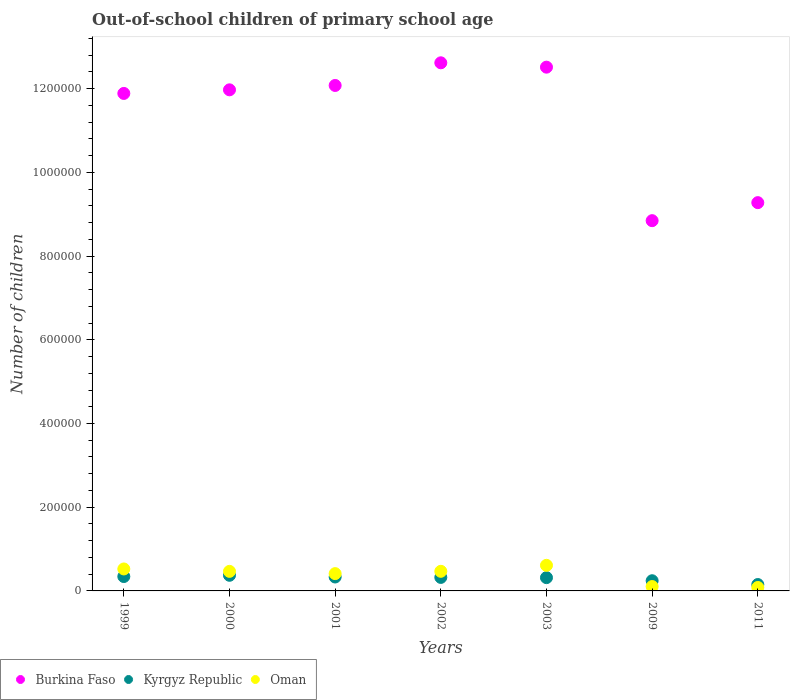What is the number of out-of-school children in Oman in 2009?
Offer a terse response. 1.05e+04. Across all years, what is the maximum number of out-of-school children in Burkina Faso?
Ensure brevity in your answer.  1.26e+06. Across all years, what is the minimum number of out-of-school children in Kyrgyz Republic?
Keep it short and to the point. 1.53e+04. In which year was the number of out-of-school children in Oman maximum?
Your answer should be compact. 2003. What is the total number of out-of-school children in Kyrgyz Republic in the graph?
Keep it short and to the point. 2.09e+05. What is the difference between the number of out-of-school children in Oman in 1999 and that in 2000?
Offer a terse response. 5778. What is the difference between the number of out-of-school children in Oman in 2002 and the number of out-of-school children in Burkina Faso in 2001?
Provide a short and direct response. -1.16e+06. What is the average number of out-of-school children in Kyrgyz Republic per year?
Provide a short and direct response. 2.98e+04. In the year 2009, what is the difference between the number of out-of-school children in Burkina Faso and number of out-of-school children in Kyrgyz Republic?
Your response must be concise. 8.60e+05. What is the ratio of the number of out-of-school children in Oman in 2001 to that in 2003?
Offer a very short reply. 0.68. Is the difference between the number of out-of-school children in Burkina Faso in 2001 and 2002 greater than the difference between the number of out-of-school children in Kyrgyz Republic in 2001 and 2002?
Your response must be concise. No. What is the difference between the highest and the second highest number of out-of-school children in Kyrgyz Republic?
Give a very brief answer. 2965. What is the difference between the highest and the lowest number of out-of-school children in Kyrgyz Republic?
Make the answer very short. 2.21e+04. Is it the case that in every year, the sum of the number of out-of-school children in Kyrgyz Republic and number of out-of-school children in Oman  is greater than the number of out-of-school children in Burkina Faso?
Your response must be concise. No. Is the number of out-of-school children in Burkina Faso strictly less than the number of out-of-school children in Kyrgyz Republic over the years?
Make the answer very short. No. Are the values on the major ticks of Y-axis written in scientific E-notation?
Offer a very short reply. No. How many legend labels are there?
Ensure brevity in your answer.  3. How are the legend labels stacked?
Keep it short and to the point. Horizontal. What is the title of the graph?
Your answer should be very brief. Out-of-school children of primary school age. What is the label or title of the Y-axis?
Your answer should be very brief. Number of children. What is the Number of children of Burkina Faso in 1999?
Give a very brief answer. 1.19e+06. What is the Number of children of Kyrgyz Republic in 1999?
Keep it short and to the point. 3.44e+04. What is the Number of children of Oman in 1999?
Ensure brevity in your answer.  5.25e+04. What is the Number of children in Burkina Faso in 2000?
Provide a short and direct response. 1.20e+06. What is the Number of children in Kyrgyz Republic in 2000?
Give a very brief answer. 3.73e+04. What is the Number of children in Oman in 2000?
Offer a terse response. 4.67e+04. What is the Number of children of Burkina Faso in 2001?
Provide a short and direct response. 1.21e+06. What is the Number of children in Kyrgyz Republic in 2001?
Your answer should be compact. 3.33e+04. What is the Number of children in Oman in 2001?
Your response must be concise. 4.13e+04. What is the Number of children in Burkina Faso in 2002?
Offer a terse response. 1.26e+06. What is the Number of children in Kyrgyz Republic in 2002?
Provide a short and direct response. 3.23e+04. What is the Number of children of Oman in 2002?
Make the answer very short. 4.68e+04. What is the Number of children of Burkina Faso in 2003?
Ensure brevity in your answer.  1.25e+06. What is the Number of children in Kyrgyz Republic in 2003?
Your answer should be compact. 3.17e+04. What is the Number of children of Oman in 2003?
Keep it short and to the point. 6.11e+04. What is the Number of children in Burkina Faso in 2009?
Make the answer very short. 8.85e+05. What is the Number of children in Kyrgyz Republic in 2009?
Ensure brevity in your answer.  2.43e+04. What is the Number of children of Oman in 2009?
Give a very brief answer. 1.05e+04. What is the Number of children of Burkina Faso in 2011?
Offer a terse response. 9.28e+05. What is the Number of children of Kyrgyz Republic in 2011?
Offer a very short reply. 1.53e+04. What is the Number of children in Oman in 2011?
Your response must be concise. 8213. Across all years, what is the maximum Number of children of Burkina Faso?
Offer a very short reply. 1.26e+06. Across all years, what is the maximum Number of children in Kyrgyz Republic?
Your answer should be compact. 3.73e+04. Across all years, what is the maximum Number of children in Oman?
Keep it short and to the point. 6.11e+04. Across all years, what is the minimum Number of children of Burkina Faso?
Your answer should be compact. 8.85e+05. Across all years, what is the minimum Number of children of Kyrgyz Republic?
Provide a succinct answer. 1.53e+04. Across all years, what is the minimum Number of children in Oman?
Your response must be concise. 8213. What is the total Number of children of Burkina Faso in the graph?
Your response must be concise. 7.92e+06. What is the total Number of children in Kyrgyz Republic in the graph?
Keep it short and to the point. 2.09e+05. What is the total Number of children in Oman in the graph?
Make the answer very short. 2.67e+05. What is the difference between the Number of children in Burkina Faso in 1999 and that in 2000?
Provide a succinct answer. -8593. What is the difference between the Number of children in Kyrgyz Republic in 1999 and that in 2000?
Provide a succinct answer. -2965. What is the difference between the Number of children in Oman in 1999 and that in 2000?
Give a very brief answer. 5778. What is the difference between the Number of children in Burkina Faso in 1999 and that in 2001?
Your answer should be very brief. -1.90e+04. What is the difference between the Number of children of Kyrgyz Republic in 1999 and that in 2001?
Provide a short and direct response. 1127. What is the difference between the Number of children of Oman in 1999 and that in 2001?
Your response must be concise. 1.12e+04. What is the difference between the Number of children in Burkina Faso in 1999 and that in 2002?
Your response must be concise. -7.32e+04. What is the difference between the Number of children in Kyrgyz Republic in 1999 and that in 2002?
Your answer should be very brief. 2106. What is the difference between the Number of children in Oman in 1999 and that in 2002?
Provide a succinct answer. 5643. What is the difference between the Number of children of Burkina Faso in 1999 and that in 2003?
Provide a succinct answer. -6.28e+04. What is the difference between the Number of children in Kyrgyz Republic in 1999 and that in 2003?
Make the answer very short. 2649. What is the difference between the Number of children of Oman in 1999 and that in 2003?
Your answer should be compact. -8659. What is the difference between the Number of children of Burkina Faso in 1999 and that in 2009?
Ensure brevity in your answer.  3.04e+05. What is the difference between the Number of children of Kyrgyz Republic in 1999 and that in 2009?
Ensure brevity in your answer.  1.01e+04. What is the difference between the Number of children in Oman in 1999 and that in 2009?
Your response must be concise. 4.20e+04. What is the difference between the Number of children of Burkina Faso in 1999 and that in 2011?
Make the answer very short. 2.61e+05. What is the difference between the Number of children of Kyrgyz Republic in 1999 and that in 2011?
Your answer should be compact. 1.91e+04. What is the difference between the Number of children of Oman in 1999 and that in 2011?
Provide a short and direct response. 4.43e+04. What is the difference between the Number of children of Burkina Faso in 2000 and that in 2001?
Your answer should be very brief. -1.05e+04. What is the difference between the Number of children of Kyrgyz Republic in 2000 and that in 2001?
Make the answer very short. 4092. What is the difference between the Number of children of Oman in 2000 and that in 2001?
Ensure brevity in your answer.  5378. What is the difference between the Number of children in Burkina Faso in 2000 and that in 2002?
Your answer should be very brief. -6.46e+04. What is the difference between the Number of children of Kyrgyz Republic in 2000 and that in 2002?
Give a very brief answer. 5071. What is the difference between the Number of children of Oman in 2000 and that in 2002?
Keep it short and to the point. -135. What is the difference between the Number of children in Burkina Faso in 2000 and that in 2003?
Offer a terse response. -5.42e+04. What is the difference between the Number of children of Kyrgyz Republic in 2000 and that in 2003?
Your answer should be compact. 5614. What is the difference between the Number of children of Oman in 2000 and that in 2003?
Offer a terse response. -1.44e+04. What is the difference between the Number of children in Burkina Faso in 2000 and that in 2009?
Offer a terse response. 3.13e+05. What is the difference between the Number of children in Kyrgyz Republic in 2000 and that in 2009?
Provide a succinct answer. 1.30e+04. What is the difference between the Number of children of Oman in 2000 and that in 2009?
Provide a succinct answer. 3.62e+04. What is the difference between the Number of children in Burkina Faso in 2000 and that in 2011?
Ensure brevity in your answer.  2.70e+05. What is the difference between the Number of children in Kyrgyz Republic in 2000 and that in 2011?
Provide a succinct answer. 2.21e+04. What is the difference between the Number of children of Oman in 2000 and that in 2011?
Offer a terse response. 3.85e+04. What is the difference between the Number of children of Burkina Faso in 2001 and that in 2002?
Give a very brief answer. -5.41e+04. What is the difference between the Number of children in Kyrgyz Republic in 2001 and that in 2002?
Your answer should be very brief. 979. What is the difference between the Number of children of Oman in 2001 and that in 2002?
Your answer should be very brief. -5513. What is the difference between the Number of children in Burkina Faso in 2001 and that in 2003?
Keep it short and to the point. -4.37e+04. What is the difference between the Number of children in Kyrgyz Republic in 2001 and that in 2003?
Offer a very short reply. 1522. What is the difference between the Number of children of Oman in 2001 and that in 2003?
Offer a terse response. -1.98e+04. What is the difference between the Number of children of Burkina Faso in 2001 and that in 2009?
Provide a short and direct response. 3.23e+05. What is the difference between the Number of children of Kyrgyz Republic in 2001 and that in 2009?
Give a very brief answer. 8935. What is the difference between the Number of children in Oman in 2001 and that in 2009?
Your response must be concise. 3.09e+04. What is the difference between the Number of children of Burkina Faso in 2001 and that in 2011?
Your answer should be compact. 2.80e+05. What is the difference between the Number of children in Kyrgyz Republic in 2001 and that in 2011?
Your answer should be very brief. 1.80e+04. What is the difference between the Number of children of Oman in 2001 and that in 2011?
Keep it short and to the point. 3.31e+04. What is the difference between the Number of children in Burkina Faso in 2002 and that in 2003?
Your answer should be very brief. 1.04e+04. What is the difference between the Number of children of Kyrgyz Republic in 2002 and that in 2003?
Offer a very short reply. 543. What is the difference between the Number of children of Oman in 2002 and that in 2003?
Provide a short and direct response. -1.43e+04. What is the difference between the Number of children in Burkina Faso in 2002 and that in 2009?
Offer a very short reply. 3.77e+05. What is the difference between the Number of children in Kyrgyz Republic in 2002 and that in 2009?
Provide a succinct answer. 7956. What is the difference between the Number of children of Oman in 2002 and that in 2009?
Your response must be concise. 3.64e+04. What is the difference between the Number of children in Burkina Faso in 2002 and that in 2011?
Ensure brevity in your answer.  3.34e+05. What is the difference between the Number of children in Kyrgyz Republic in 2002 and that in 2011?
Your answer should be very brief. 1.70e+04. What is the difference between the Number of children of Oman in 2002 and that in 2011?
Provide a succinct answer. 3.86e+04. What is the difference between the Number of children of Burkina Faso in 2003 and that in 2009?
Offer a terse response. 3.67e+05. What is the difference between the Number of children of Kyrgyz Republic in 2003 and that in 2009?
Ensure brevity in your answer.  7413. What is the difference between the Number of children in Oman in 2003 and that in 2009?
Give a very brief answer. 5.07e+04. What is the difference between the Number of children of Burkina Faso in 2003 and that in 2011?
Offer a terse response. 3.24e+05. What is the difference between the Number of children in Kyrgyz Republic in 2003 and that in 2011?
Give a very brief answer. 1.65e+04. What is the difference between the Number of children in Oman in 2003 and that in 2011?
Provide a short and direct response. 5.29e+04. What is the difference between the Number of children of Burkina Faso in 2009 and that in 2011?
Provide a succinct answer. -4.31e+04. What is the difference between the Number of children in Kyrgyz Republic in 2009 and that in 2011?
Give a very brief answer. 9065. What is the difference between the Number of children in Oman in 2009 and that in 2011?
Keep it short and to the point. 2264. What is the difference between the Number of children in Burkina Faso in 1999 and the Number of children in Kyrgyz Republic in 2000?
Your answer should be compact. 1.15e+06. What is the difference between the Number of children in Burkina Faso in 1999 and the Number of children in Oman in 2000?
Provide a short and direct response. 1.14e+06. What is the difference between the Number of children in Kyrgyz Republic in 1999 and the Number of children in Oman in 2000?
Offer a very short reply. -1.23e+04. What is the difference between the Number of children of Burkina Faso in 1999 and the Number of children of Kyrgyz Republic in 2001?
Your answer should be very brief. 1.16e+06. What is the difference between the Number of children in Burkina Faso in 1999 and the Number of children in Oman in 2001?
Your answer should be very brief. 1.15e+06. What is the difference between the Number of children of Kyrgyz Republic in 1999 and the Number of children of Oman in 2001?
Your answer should be very brief. -6947. What is the difference between the Number of children of Burkina Faso in 1999 and the Number of children of Kyrgyz Republic in 2002?
Provide a succinct answer. 1.16e+06. What is the difference between the Number of children in Burkina Faso in 1999 and the Number of children in Oman in 2002?
Ensure brevity in your answer.  1.14e+06. What is the difference between the Number of children in Kyrgyz Republic in 1999 and the Number of children in Oman in 2002?
Your response must be concise. -1.25e+04. What is the difference between the Number of children in Burkina Faso in 1999 and the Number of children in Kyrgyz Republic in 2003?
Ensure brevity in your answer.  1.16e+06. What is the difference between the Number of children in Burkina Faso in 1999 and the Number of children in Oman in 2003?
Offer a very short reply. 1.13e+06. What is the difference between the Number of children in Kyrgyz Republic in 1999 and the Number of children in Oman in 2003?
Offer a terse response. -2.68e+04. What is the difference between the Number of children of Burkina Faso in 1999 and the Number of children of Kyrgyz Republic in 2009?
Your answer should be compact. 1.16e+06. What is the difference between the Number of children of Burkina Faso in 1999 and the Number of children of Oman in 2009?
Your response must be concise. 1.18e+06. What is the difference between the Number of children of Kyrgyz Republic in 1999 and the Number of children of Oman in 2009?
Provide a short and direct response. 2.39e+04. What is the difference between the Number of children of Burkina Faso in 1999 and the Number of children of Kyrgyz Republic in 2011?
Your answer should be very brief. 1.17e+06. What is the difference between the Number of children in Burkina Faso in 1999 and the Number of children in Oman in 2011?
Make the answer very short. 1.18e+06. What is the difference between the Number of children in Kyrgyz Republic in 1999 and the Number of children in Oman in 2011?
Provide a succinct answer. 2.62e+04. What is the difference between the Number of children of Burkina Faso in 2000 and the Number of children of Kyrgyz Republic in 2001?
Offer a terse response. 1.16e+06. What is the difference between the Number of children in Burkina Faso in 2000 and the Number of children in Oman in 2001?
Offer a terse response. 1.16e+06. What is the difference between the Number of children in Kyrgyz Republic in 2000 and the Number of children in Oman in 2001?
Ensure brevity in your answer.  -3982. What is the difference between the Number of children of Burkina Faso in 2000 and the Number of children of Kyrgyz Republic in 2002?
Ensure brevity in your answer.  1.17e+06. What is the difference between the Number of children in Burkina Faso in 2000 and the Number of children in Oman in 2002?
Give a very brief answer. 1.15e+06. What is the difference between the Number of children of Kyrgyz Republic in 2000 and the Number of children of Oman in 2002?
Make the answer very short. -9495. What is the difference between the Number of children in Burkina Faso in 2000 and the Number of children in Kyrgyz Republic in 2003?
Your response must be concise. 1.17e+06. What is the difference between the Number of children of Burkina Faso in 2000 and the Number of children of Oman in 2003?
Offer a very short reply. 1.14e+06. What is the difference between the Number of children in Kyrgyz Republic in 2000 and the Number of children in Oman in 2003?
Provide a short and direct response. -2.38e+04. What is the difference between the Number of children in Burkina Faso in 2000 and the Number of children in Kyrgyz Republic in 2009?
Keep it short and to the point. 1.17e+06. What is the difference between the Number of children of Burkina Faso in 2000 and the Number of children of Oman in 2009?
Provide a succinct answer. 1.19e+06. What is the difference between the Number of children of Kyrgyz Republic in 2000 and the Number of children of Oman in 2009?
Your answer should be very brief. 2.69e+04. What is the difference between the Number of children in Burkina Faso in 2000 and the Number of children in Kyrgyz Republic in 2011?
Make the answer very short. 1.18e+06. What is the difference between the Number of children in Burkina Faso in 2000 and the Number of children in Oman in 2011?
Ensure brevity in your answer.  1.19e+06. What is the difference between the Number of children of Kyrgyz Republic in 2000 and the Number of children of Oman in 2011?
Offer a terse response. 2.91e+04. What is the difference between the Number of children in Burkina Faso in 2001 and the Number of children in Kyrgyz Republic in 2002?
Your answer should be very brief. 1.18e+06. What is the difference between the Number of children of Burkina Faso in 2001 and the Number of children of Oman in 2002?
Make the answer very short. 1.16e+06. What is the difference between the Number of children of Kyrgyz Republic in 2001 and the Number of children of Oman in 2002?
Provide a short and direct response. -1.36e+04. What is the difference between the Number of children in Burkina Faso in 2001 and the Number of children in Kyrgyz Republic in 2003?
Give a very brief answer. 1.18e+06. What is the difference between the Number of children of Burkina Faso in 2001 and the Number of children of Oman in 2003?
Ensure brevity in your answer.  1.15e+06. What is the difference between the Number of children of Kyrgyz Republic in 2001 and the Number of children of Oman in 2003?
Your answer should be compact. -2.79e+04. What is the difference between the Number of children in Burkina Faso in 2001 and the Number of children in Kyrgyz Republic in 2009?
Ensure brevity in your answer.  1.18e+06. What is the difference between the Number of children of Burkina Faso in 2001 and the Number of children of Oman in 2009?
Ensure brevity in your answer.  1.20e+06. What is the difference between the Number of children in Kyrgyz Republic in 2001 and the Number of children in Oman in 2009?
Your response must be concise. 2.28e+04. What is the difference between the Number of children in Burkina Faso in 2001 and the Number of children in Kyrgyz Republic in 2011?
Your answer should be very brief. 1.19e+06. What is the difference between the Number of children of Burkina Faso in 2001 and the Number of children of Oman in 2011?
Make the answer very short. 1.20e+06. What is the difference between the Number of children in Kyrgyz Republic in 2001 and the Number of children in Oman in 2011?
Your response must be concise. 2.50e+04. What is the difference between the Number of children in Burkina Faso in 2002 and the Number of children in Kyrgyz Republic in 2003?
Your answer should be very brief. 1.23e+06. What is the difference between the Number of children in Burkina Faso in 2002 and the Number of children in Oman in 2003?
Your answer should be compact. 1.20e+06. What is the difference between the Number of children of Kyrgyz Republic in 2002 and the Number of children of Oman in 2003?
Your answer should be very brief. -2.89e+04. What is the difference between the Number of children in Burkina Faso in 2002 and the Number of children in Kyrgyz Republic in 2009?
Give a very brief answer. 1.24e+06. What is the difference between the Number of children in Burkina Faso in 2002 and the Number of children in Oman in 2009?
Your answer should be compact. 1.25e+06. What is the difference between the Number of children in Kyrgyz Republic in 2002 and the Number of children in Oman in 2009?
Keep it short and to the point. 2.18e+04. What is the difference between the Number of children in Burkina Faso in 2002 and the Number of children in Kyrgyz Republic in 2011?
Your response must be concise. 1.25e+06. What is the difference between the Number of children in Burkina Faso in 2002 and the Number of children in Oman in 2011?
Offer a terse response. 1.25e+06. What is the difference between the Number of children of Kyrgyz Republic in 2002 and the Number of children of Oman in 2011?
Make the answer very short. 2.41e+04. What is the difference between the Number of children in Burkina Faso in 2003 and the Number of children in Kyrgyz Republic in 2009?
Keep it short and to the point. 1.23e+06. What is the difference between the Number of children in Burkina Faso in 2003 and the Number of children in Oman in 2009?
Provide a succinct answer. 1.24e+06. What is the difference between the Number of children of Kyrgyz Republic in 2003 and the Number of children of Oman in 2009?
Ensure brevity in your answer.  2.13e+04. What is the difference between the Number of children in Burkina Faso in 2003 and the Number of children in Kyrgyz Republic in 2011?
Your response must be concise. 1.24e+06. What is the difference between the Number of children of Burkina Faso in 2003 and the Number of children of Oman in 2011?
Give a very brief answer. 1.24e+06. What is the difference between the Number of children in Kyrgyz Republic in 2003 and the Number of children in Oman in 2011?
Offer a terse response. 2.35e+04. What is the difference between the Number of children in Burkina Faso in 2009 and the Number of children in Kyrgyz Republic in 2011?
Ensure brevity in your answer.  8.69e+05. What is the difference between the Number of children of Burkina Faso in 2009 and the Number of children of Oman in 2011?
Your answer should be very brief. 8.76e+05. What is the difference between the Number of children of Kyrgyz Republic in 2009 and the Number of children of Oman in 2011?
Your response must be concise. 1.61e+04. What is the average Number of children in Burkina Faso per year?
Give a very brief answer. 1.13e+06. What is the average Number of children in Kyrgyz Republic per year?
Offer a terse response. 2.98e+04. What is the average Number of children in Oman per year?
Ensure brevity in your answer.  3.82e+04. In the year 1999, what is the difference between the Number of children of Burkina Faso and Number of children of Kyrgyz Republic?
Make the answer very short. 1.15e+06. In the year 1999, what is the difference between the Number of children in Burkina Faso and Number of children in Oman?
Your answer should be very brief. 1.14e+06. In the year 1999, what is the difference between the Number of children in Kyrgyz Republic and Number of children in Oman?
Provide a succinct answer. -1.81e+04. In the year 2000, what is the difference between the Number of children of Burkina Faso and Number of children of Kyrgyz Republic?
Make the answer very short. 1.16e+06. In the year 2000, what is the difference between the Number of children of Burkina Faso and Number of children of Oman?
Your response must be concise. 1.15e+06. In the year 2000, what is the difference between the Number of children of Kyrgyz Republic and Number of children of Oman?
Provide a short and direct response. -9360. In the year 2001, what is the difference between the Number of children of Burkina Faso and Number of children of Kyrgyz Republic?
Give a very brief answer. 1.17e+06. In the year 2001, what is the difference between the Number of children of Burkina Faso and Number of children of Oman?
Offer a terse response. 1.17e+06. In the year 2001, what is the difference between the Number of children in Kyrgyz Republic and Number of children in Oman?
Your answer should be compact. -8074. In the year 2002, what is the difference between the Number of children of Burkina Faso and Number of children of Kyrgyz Republic?
Your response must be concise. 1.23e+06. In the year 2002, what is the difference between the Number of children of Burkina Faso and Number of children of Oman?
Your response must be concise. 1.22e+06. In the year 2002, what is the difference between the Number of children of Kyrgyz Republic and Number of children of Oman?
Your response must be concise. -1.46e+04. In the year 2003, what is the difference between the Number of children in Burkina Faso and Number of children in Kyrgyz Republic?
Offer a terse response. 1.22e+06. In the year 2003, what is the difference between the Number of children in Burkina Faso and Number of children in Oman?
Provide a short and direct response. 1.19e+06. In the year 2003, what is the difference between the Number of children of Kyrgyz Republic and Number of children of Oman?
Ensure brevity in your answer.  -2.94e+04. In the year 2009, what is the difference between the Number of children in Burkina Faso and Number of children in Kyrgyz Republic?
Provide a short and direct response. 8.60e+05. In the year 2009, what is the difference between the Number of children of Burkina Faso and Number of children of Oman?
Keep it short and to the point. 8.74e+05. In the year 2009, what is the difference between the Number of children in Kyrgyz Republic and Number of children in Oman?
Give a very brief answer. 1.38e+04. In the year 2011, what is the difference between the Number of children of Burkina Faso and Number of children of Kyrgyz Republic?
Your answer should be compact. 9.12e+05. In the year 2011, what is the difference between the Number of children of Burkina Faso and Number of children of Oman?
Offer a very short reply. 9.20e+05. In the year 2011, what is the difference between the Number of children of Kyrgyz Republic and Number of children of Oman?
Provide a short and direct response. 7043. What is the ratio of the Number of children in Burkina Faso in 1999 to that in 2000?
Give a very brief answer. 0.99. What is the ratio of the Number of children in Kyrgyz Republic in 1999 to that in 2000?
Give a very brief answer. 0.92. What is the ratio of the Number of children of Oman in 1999 to that in 2000?
Make the answer very short. 1.12. What is the ratio of the Number of children in Burkina Faso in 1999 to that in 2001?
Ensure brevity in your answer.  0.98. What is the ratio of the Number of children of Kyrgyz Republic in 1999 to that in 2001?
Give a very brief answer. 1.03. What is the ratio of the Number of children in Oman in 1999 to that in 2001?
Make the answer very short. 1.27. What is the ratio of the Number of children of Burkina Faso in 1999 to that in 2002?
Your answer should be very brief. 0.94. What is the ratio of the Number of children of Kyrgyz Republic in 1999 to that in 2002?
Ensure brevity in your answer.  1.07. What is the ratio of the Number of children in Oman in 1999 to that in 2002?
Your response must be concise. 1.12. What is the ratio of the Number of children in Burkina Faso in 1999 to that in 2003?
Offer a terse response. 0.95. What is the ratio of the Number of children of Kyrgyz Republic in 1999 to that in 2003?
Ensure brevity in your answer.  1.08. What is the ratio of the Number of children of Oman in 1999 to that in 2003?
Give a very brief answer. 0.86. What is the ratio of the Number of children of Burkina Faso in 1999 to that in 2009?
Offer a very short reply. 1.34. What is the ratio of the Number of children of Kyrgyz Republic in 1999 to that in 2009?
Your response must be concise. 1.41. What is the ratio of the Number of children in Oman in 1999 to that in 2009?
Give a very brief answer. 5.01. What is the ratio of the Number of children in Burkina Faso in 1999 to that in 2011?
Offer a very short reply. 1.28. What is the ratio of the Number of children of Kyrgyz Republic in 1999 to that in 2011?
Your response must be concise. 2.25. What is the ratio of the Number of children in Oman in 1999 to that in 2011?
Your answer should be compact. 6.39. What is the ratio of the Number of children in Burkina Faso in 2000 to that in 2001?
Provide a succinct answer. 0.99. What is the ratio of the Number of children in Kyrgyz Republic in 2000 to that in 2001?
Offer a terse response. 1.12. What is the ratio of the Number of children of Oman in 2000 to that in 2001?
Your response must be concise. 1.13. What is the ratio of the Number of children of Burkina Faso in 2000 to that in 2002?
Offer a terse response. 0.95. What is the ratio of the Number of children of Kyrgyz Republic in 2000 to that in 2002?
Your answer should be very brief. 1.16. What is the ratio of the Number of children in Oman in 2000 to that in 2002?
Your answer should be compact. 1. What is the ratio of the Number of children of Burkina Faso in 2000 to that in 2003?
Give a very brief answer. 0.96. What is the ratio of the Number of children in Kyrgyz Republic in 2000 to that in 2003?
Your answer should be very brief. 1.18. What is the ratio of the Number of children in Oman in 2000 to that in 2003?
Your answer should be very brief. 0.76. What is the ratio of the Number of children of Burkina Faso in 2000 to that in 2009?
Make the answer very short. 1.35. What is the ratio of the Number of children in Kyrgyz Republic in 2000 to that in 2009?
Offer a very short reply. 1.54. What is the ratio of the Number of children of Oman in 2000 to that in 2009?
Offer a terse response. 4.46. What is the ratio of the Number of children of Burkina Faso in 2000 to that in 2011?
Provide a short and direct response. 1.29. What is the ratio of the Number of children of Kyrgyz Republic in 2000 to that in 2011?
Your answer should be very brief. 2.45. What is the ratio of the Number of children of Oman in 2000 to that in 2011?
Provide a succinct answer. 5.69. What is the ratio of the Number of children of Burkina Faso in 2001 to that in 2002?
Provide a short and direct response. 0.96. What is the ratio of the Number of children in Kyrgyz Republic in 2001 to that in 2002?
Give a very brief answer. 1.03. What is the ratio of the Number of children in Oman in 2001 to that in 2002?
Provide a short and direct response. 0.88. What is the ratio of the Number of children of Burkina Faso in 2001 to that in 2003?
Provide a short and direct response. 0.97. What is the ratio of the Number of children in Kyrgyz Republic in 2001 to that in 2003?
Your answer should be very brief. 1.05. What is the ratio of the Number of children of Oman in 2001 to that in 2003?
Provide a short and direct response. 0.68. What is the ratio of the Number of children in Burkina Faso in 2001 to that in 2009?
Your response must be concise. 1.37. What is the ratio of the Number of children of Kyrgyz Republic in 2001 to that in 2009?
Your answer should be very brief. 1.37. What is the ratio of the Number of children of Oman in 2001 to that in 2009?
Provide a short and direct response. 3.94. What is the ratio of the Number of children in Burkina Faso in 2001 to that in 2011?
Make the answer very short. 1.3. What is the ratio of the Number of children of Kyrgyz Republic in 2001 to that in 2011?
Give a very brief answer. 2.18. What is the ratio of the Number of children in Oman in 2001 to that in 2011?
Make the answer very short. 5.03. What is the ratio of the Number of children in Burkina Faso in 2002 to that in 2003?
Your response must be concise. 1.01. What is the ratio of the Number of children of Kyrgyz Republic in 2002 to that in 2003?
Offer a terse response. 1.02. What is the ratio of the Number of children in Oman in 2002 to that in 2003?
Offer a very short reply. 0.77. What is the ratio of the Number of children of Burkina Faso in 2002 to that in 2009?
Keep it short and to the point. 1.43. What is the ratio of the Number of children in Kyrgyz Republic in 2002 to that in 2009?
Keep it short and to the point. 1.33. What is the ratio of the Number of children in Oman in 2002 to that in 2009?
Ensure brevity in your answer.  4.47. What is the ratio of the Number of children of Burkina Faso in 2002 to that in 2011?
Ensure brevity in your answer.  1.36. What is the ratio of the Number of children of Kyrgyz Republic in 2002 to that in 2011?
Make the answer very short. 2.12. What is the ratio of the Number of children of Oman in 2002 to that in 2011?
Offer a terse response. 5.7. What is the ratio of the Number of children in Burkina Faso in 2003 to that in 2009?
Give a very brief answer. 1.41. What is the ratio of the Number of children of Kyrgyz Republic in 2003 to that in 2009?
Offer a very short reply. 1.3. What is the ratio of the Number of children in Oman in 2003 to that in 2009?
Give a very brief answer. 5.84. What is the ratio of the Number of children of Burkina Faso in 2003 to that in 2011?
Offer a terse response. 1.35. What is the ratio of the Number of children in Kyrgyz Republic in 2003 to that in 2011?
Make the answer very short. 2.08. What is the ratio of the Number of children in Oman in 2003 to that in 2011?
Provide a succinct answer. 7.44. What is the ratio of the Number of children of Burkina Faso in 2009 to that in 2011?
Ensure brevity in your answer.  0.95. What is the ratio of the Number of children of Kyrgyz Republic in 2009 to that in 2011?
Your answer should be compact. 1.59. What is the ratio of the Number of children in Oman in 2009 to that in 2011?
Provide a succinct answer. 1.28. What is the difference between the highest and the second highest Number of children of Burkina Faso?
Your answer should be very brief. 1.04e+04. What is the difference between the highest and the second highest Number of children in Kyrgyz Republic?
Offer a terse response. 2965. What is the difference between the highest and the second highest Number of children in Oman?
Give a very brief answer. 8659. What is the difference between the highest and the lowest Number of children of Burkina Faso?
Offer a very short reply. 3.77e+05. What is the difference between the highest and the lowest Number of children in Kyrgyz Republic?
Your answer should be very brief. 2.21e+04. What is the difference between the highest and the lowest Number of children of Oman?
Your response must be concise. 5.29e+04. 